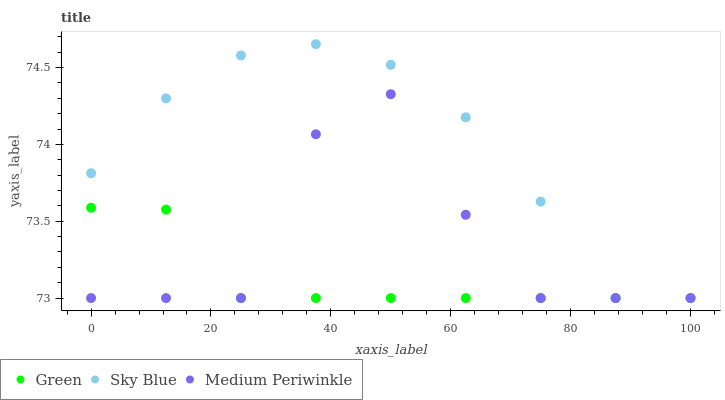Does Green have the minimum area under the curve?
Answer yes or no. Yes. Does Sky Blue have the maximum area under the curve?
Answer yes or no. Yes. Does Medium Periwinkle have the minimum area under the curve?
Answer yes or no. No. Does Medium Periwinkle have the maximum area under the curve?
Answer yes or no. No. Is Green the smoothest?
Answer yes or no. Yes. Is Medium Periwinkle the roughest?
Answer yes or no. Yes. Is Medium Periwinkle the smoothest?
Answer yes or no. No. Is Green the roughest?
Answer yes or no. No. Does Sky Blue have the lowest value?
Answer yes or no. Yes. Does Sky Blue have the highest value?
Answer yes or no. Yes. Does Medium Periwinkle have the highest value?
Answer yes or no. No. Does Sky Blue intersect Green?
Answer yes or no. Yes. Is Sky Blue less than Green?
Answer yes or no. No. Is Sky Blue greater than Green?
Answer yes or no. No. 